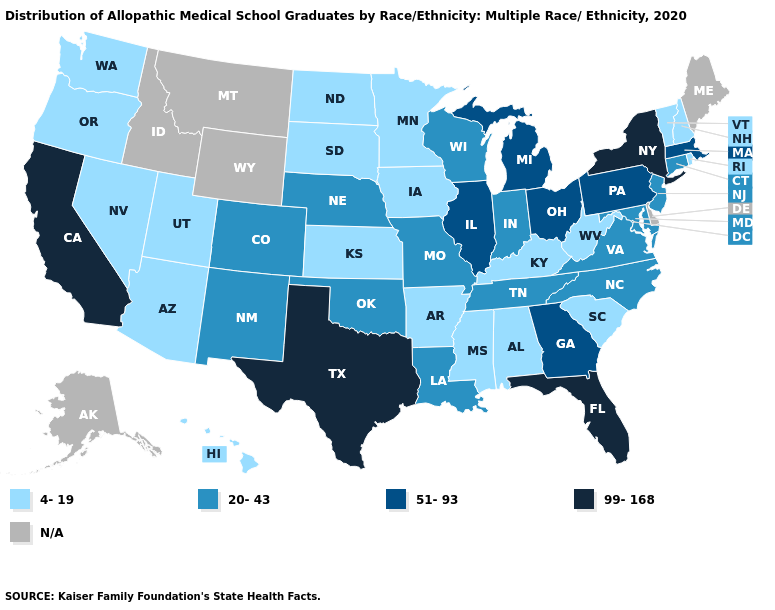What is the lowest value in the USA?
Be succinct. 4-19. Which states have the lowest value in the USA?
Keep it brief. Alabama, Arizona, Arkansas, Hawaii, Iowa, Kansas, Kentucky, Minnesota, Mississippi, Nevada, New Hampshire, North Dakota, Oregon, Rhode Island, South Carolina, South Dakota, Utah, Vermont, Washington, West Virginia. Does North Carolina have the highest value in the USA?
Be succinct. No. Name the states that have a value in the range N/A?
Quick response, please. Alaska, Delaware, Idaho, Maine, Montana, Wyoming. Name the states that have a value in the range 99-168?
Quick response, please. California, Florida, New York, Texas. Name the states that have a value in the range 51-93?
Keep it brief. Georgia, Illinois, Massachusetts, Michigan, Ohio, Pennsylvania. What is the highest value in the USA?
Quick response, please. 99-168. Which states have the lowest value in the Northeast?
Concise answer only. New Hampshire, Rhode Island, Vermont. Does New Mexico have the lowest value in the USA?
Be succinct. No. What is the highest value in states that border Minnesota?
Quick response, please. 20-43. Name the states that have a value in the range 4-19?
Be succinct. Alabama, Arizona, Arkansas, Hawaii, Iowa, Kansas, Kentucky, Minnesota, Mississippi, Nevada, New Hampshire, North Dakota, Oregon, Rhode Island, South Carolina, South Dakota, Utah, Vermont, Washington, West Virginia. Which states have the lowest value in the USA?
Keep it brief. Alabama, Arizona, Arkansas, Hawaii, Iowa, Kansas, Kentucky, Minnesota, Mississippi, Nevada, New Hampshire, North Dakota, Oregon, Rhode Island, South Carolina, South Dakota, Utah, Vermont, Washington, West Virginia. Name the states that have a value in the range N/A?
Short answer required. Alaska, Delaware, Idaho, Maine, Montana, Wyoming. What is the value of Colorado?
Give a very brief answer. 20-43. 